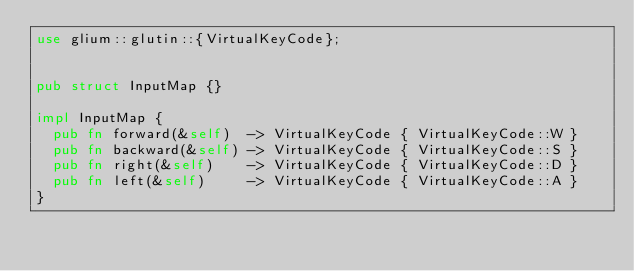<code> <loc_0><loc_0><loc_500><loc_500><_Rust_>use glium::glutin::{VirtualKeyCode};


pub struct InputMap {}

impl InputMap {
	pub fn forward(&self)  -> VirtualKeyCode { VirtualKeyCode::W }
	pub fn backward(&self) -> VirtualKeyCode { VirtualKeyCode::S }
	pub fn right(&self)    -> VirtualKeyCode { VirtualKeyCode::D }
	pub fn left(&self)     -> VirtualKeyCode { VirtualKeyCode::A }
}
</code> 